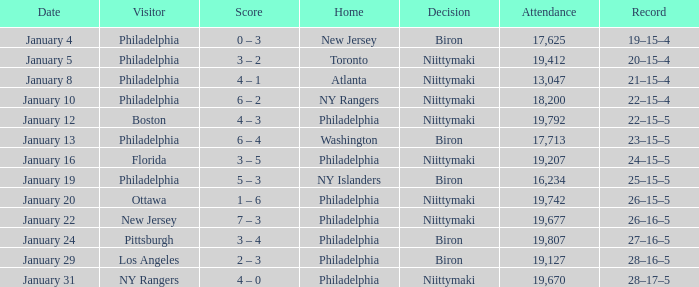Which team was the visitor on January 10? Philadelphia. 